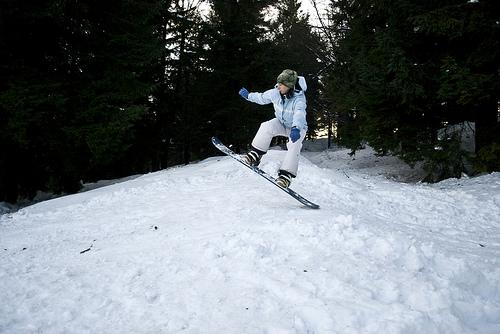List three colors mentioned in the image information and the objects associated with them. Blue - jacket, gloves, snowboard; white - snow pants, snow; green - trees, knit hat. Which task would require identifying colors and objects in the image? Referential expression grounding task. Which objects from the image information contribute to depicting the snowboarding trick? The blue snowboard raised in midair, the snowboarder's position, and the mound of snow she is jumping over. Which task would involve figuring out if the captions describe the image accurately? Visual entailment task. What is the primary activity happening in the image? A girl is snowboarding while performing a trick with the nose of her blue snowboard raised in midair. What type of ad could this image be used for? A snowboarding gear or ski resort advertisement. Describe the environment around the snowboarder. The snowboarder is jumping over a mound on a white, packed snowy slope with green evergreen trees and brown twigs in the background. Can you describe the snowboarder's outfit? The snowboarder is wearing a blue jacket with a hoodie, white snow pants, blue gloves, a camouflage knit cap, and black snowboard boots. What is the hair color of the snowboarder, and what hairstyle does she have? Is she wearing anything on her head? The girl has long dark hair and is wearing a green and beige camouflage knit cap. 